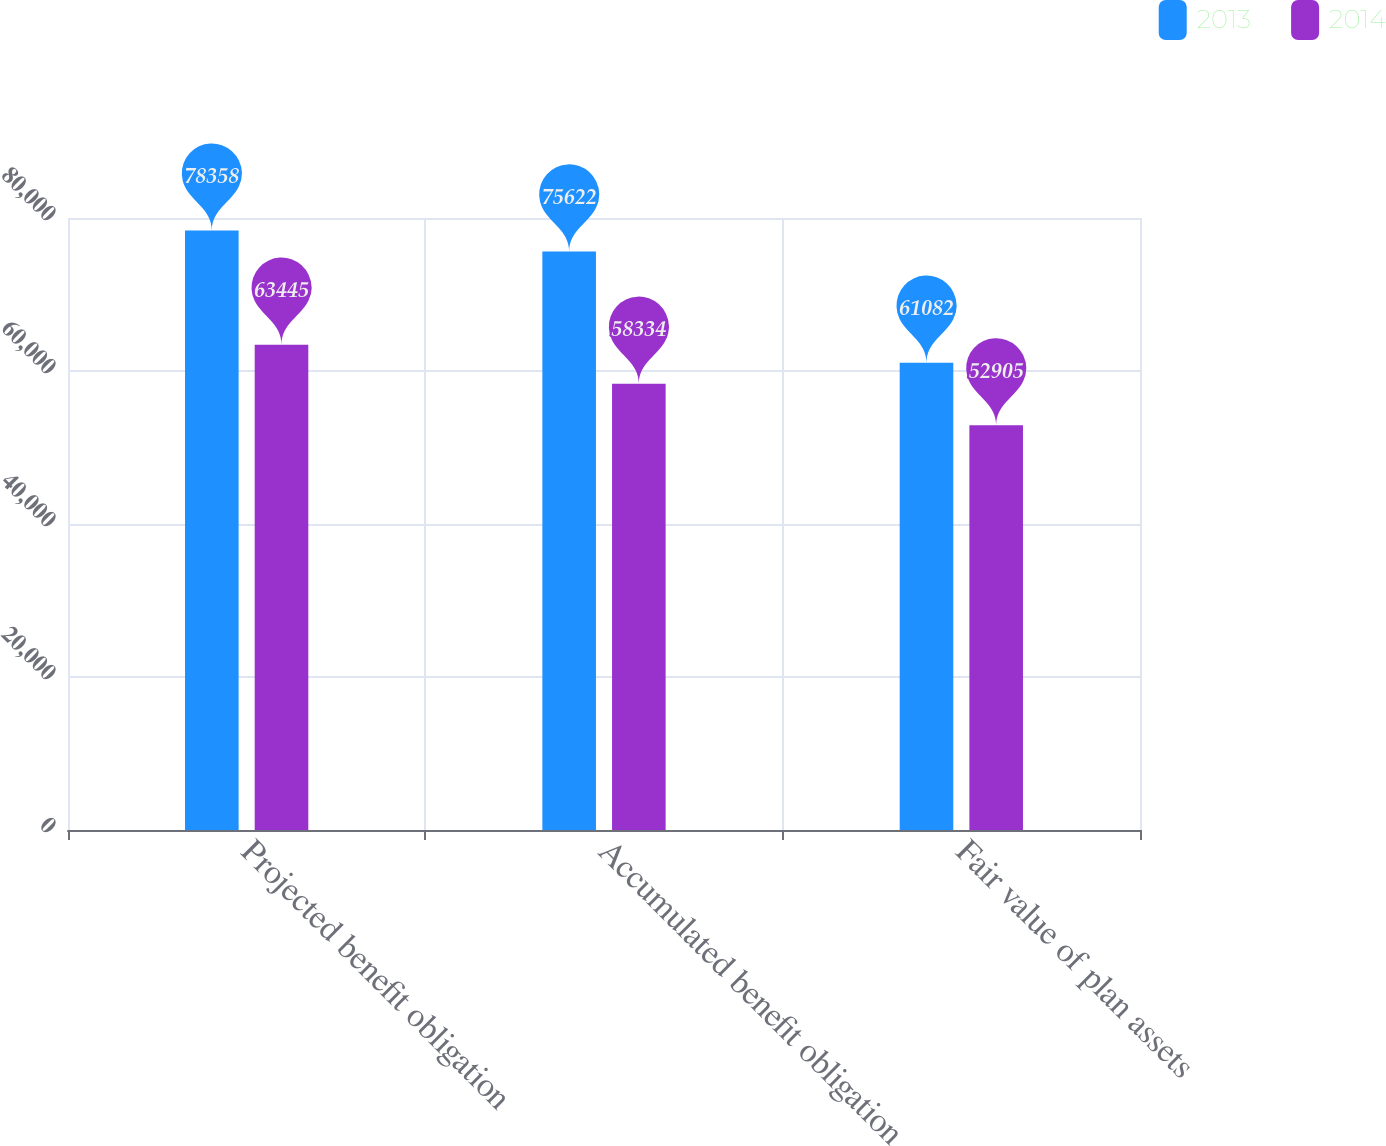<chart> <loc_0><loc_0><loc_500><loc_500><stacked_bar_chart><ecel><fcel>Projected benefit obligation<fcel>Accumulated benefit obligation<fcel>Fair value of plan assets<nl><fcel>2013<fcel>78358<fcel>75622<fcel>61082<nl><fcel>2014<fcel>63445<fcel>58334<fcel>52905<nl></chart> 